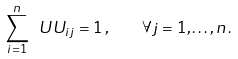Convert formula to latex. <formula><loc_0><loc_0><loc_500><loc_500>\sum _ { i = 1 } ^ { n } \ U U _ { i j } = 1 \, , \quad \forall j = 1 , \dots , n \, .</formula> 